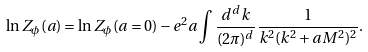<formula> <loc_0><loc_0><loc_500><loc_500>\ln Z _ { \phi } ( a ) = \ln Z _ { \phi } ( a = 0 ) - e ^ { 2 } a \int \frac { d ^ { d } k } { ( 2 \pi ) ^ { d } } \frac { 1 } { k ^ { 2 } ( k ^ { 2 } + a M ^ { 2 } ) ^ { 2 } } .</formula> 